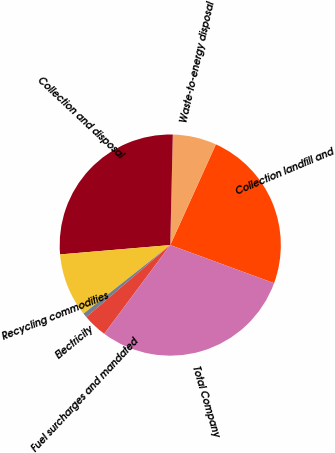Convert chart. <chart><loc_0><loc_0><loc_500><loc_500><pie_chart><fcel>Collection landfill and<fcel>Waste-to-energy disposal<fcel>Collection and disposal<fcel>Recycling commodities<fcel>Electricity<fcel>Fuel surcharges and mandated<fcel>Total Company<nl><fcel>23.82%<fcel>6.41%<fcel>26.71%<fcel>9.3%<fcel>0.64%<fcel>3.53%<fcel>29.59%<nl></chart> 